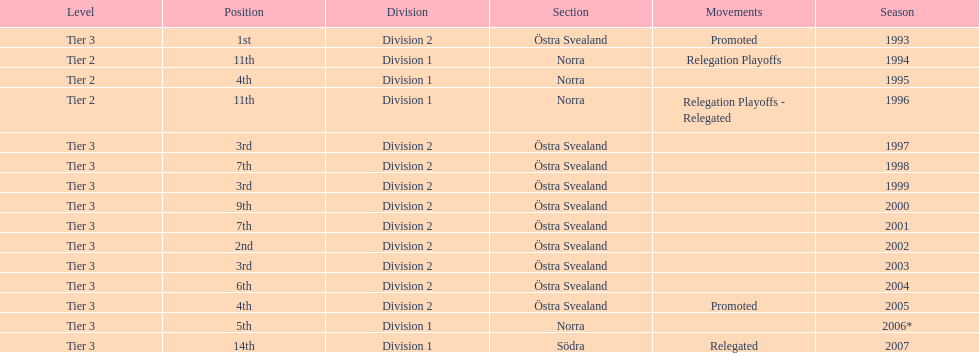What section did they play in the most? Östra Svealand. 